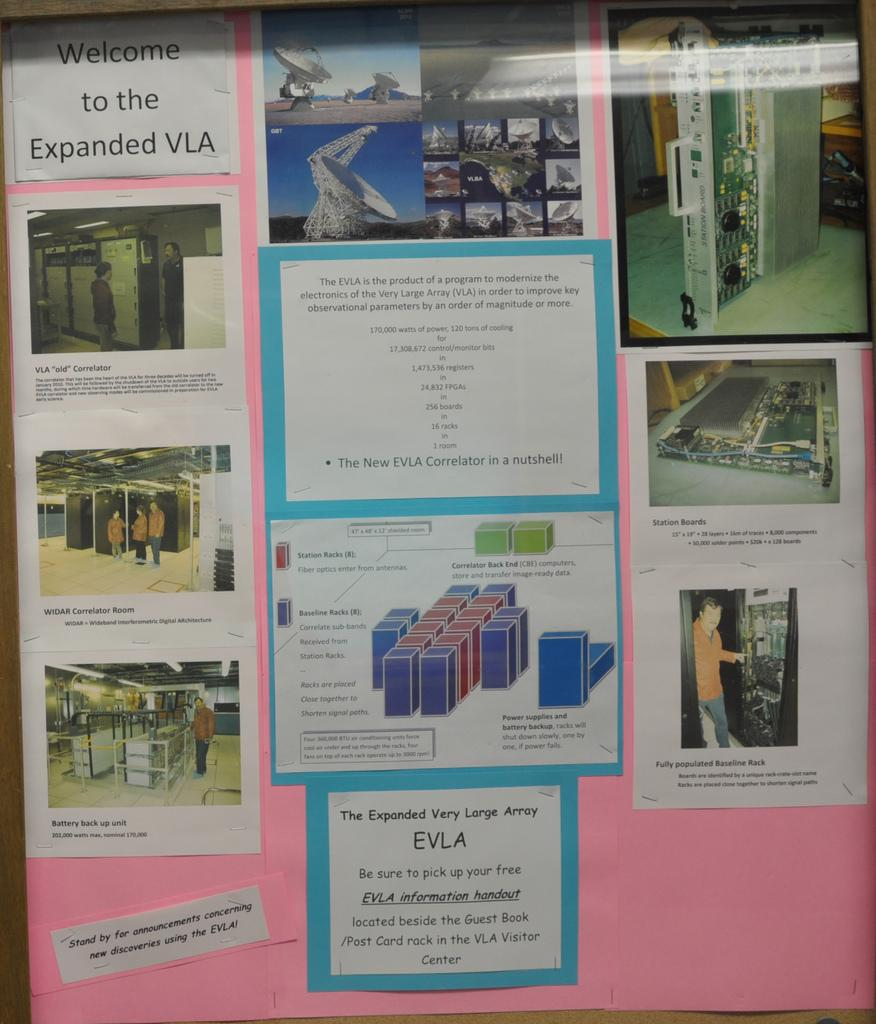<image>
Provide a brief description of the given image. Display with pink background that says "Welcome to the Expanded VLA". 